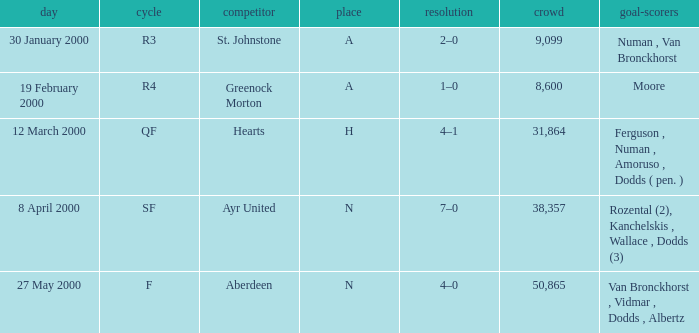Who was in a with opponent St. Johnstone? Numan , Van Bronckhorst. 